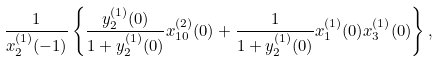Convert formula to latex. <formula><loc_0><loc_0><loc_500><loc_500>\frac { 1 } { x ^ { ( 1 ) } _ { 2 } ( - 1 ) } \left \{ \frac { y ^ { ( 1 ) } _ { 2 } ( 0 ) } { 1 + y ^ { ( 1 ) } _ { 2 } ( 0 ) } x ^ { ( 2 ) } _ { 1 0 } ( 0 ) + \frac { 1 } { 1 + y ^ { ( 1 ) } _ { 2 } ( 0 ) } x ^ { ( 1 ) } _ { 1 } ( 0 ) x ^ { ( 1 ) } _ { 3 } ( 0 ) \right \} ,</formula> 